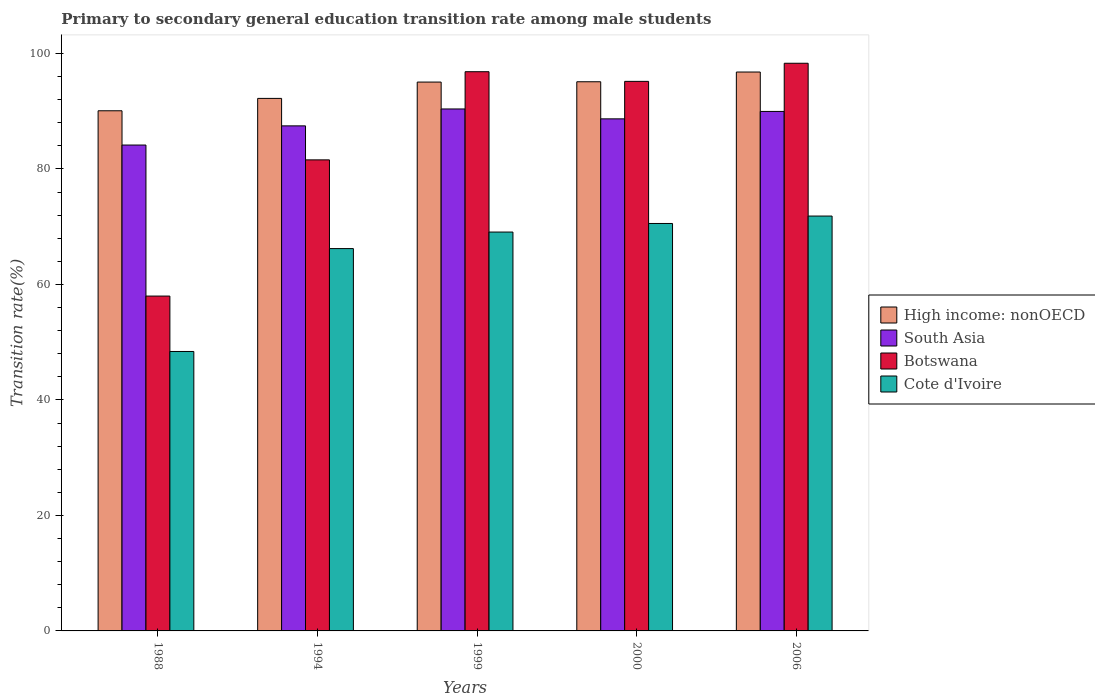How many different coloured bars are there?
Provide a short and direct response. 4. How many bars are there on the 2nd tick from the left?
Keep it short and to the point. 4. How many bars are there on the 3rd tick from the right?
Make the answer very short. 4. What is the label of the 1st group of bars from the left?
Keep it short and to the point. 1988. What is the transition rate in High income: nonOECD in 1999?
Give a very brief answer. 95.05. Across all years, what is the maximum transition rate in Botswana?
Provide a succinct answer. 98.3. Across all years, what is the minimum transition rate in South Asia?
Make the answer very short. 84.14. In which year was the transition rate in Cote d'Ivoire minimum?
Your response must be concise. 1988. What is the total transition rate in High income: nonOECD in the graph?
Your answer should be very brief. 469.22. What is the difference between the transition rate in Botswana in 1988 and that in 2000?
Give a very brief answer. -37.18. What is the difference between the transition rate in High income: nonOECD in 2000 and the transition rate in Botswana in 2006?
Provide a succinct answer. -3.2. What is the average transition rate in South Asia per year?
Your answer should be very brief. 88.13. In the year 2000, what is the difference between the transition rate in Botswana and transition rate in High income: nonOECD?
Your answer should be very brief. 0.07. What is the ratio of the transition rate in Botswana in 1988 to that in 1999?
Offer a terse response. 0.6. What is the difference between the highest and the second highest transition rate in High income: nonOECD?
Provide a short and direct response. 1.69. What is the difference between the highest and the lowest transition rate in Botswana?
Ensure brevity in your answer.  40.32. In how many years, is the transition rate in Cote d'Ivoire greater than the average transition rate in Cote d'Ivoire taken over all years?
Keep it short and to the point. 4. Is the sum of the transition rate in South Asia in 1994 and 2000 greater than the maximum transition rate in High income: nonOECD across all years?
Your answer should be compact. Yes. What does the 1st bar from the left in 2006 represents?
Your response must be concise. High income: nonOECD. What does the 1st bar from the right in 1988 represents?
Give a very brief answer. Cote d'Ivoire. Is it the case that in every year, the sum of the transition rate in High income: nonOECD and transition rate in Cote d'Ivoire is greater than the transition rate in South Asia?
Give a very brief answer. Yes. How many years are there in the graph?
Give a very brief answer. 5. How many legend labels are there?
Make the answer very short. 4. How are the legend labels stacked?
Ensure brevity in your answer.  Vertical. What is the title of the graph?
Give a very brief answer. Primary to secondary general education transition rate among male students. Does "Virgin Islands" appear as one of the legend labels in the graph?
Ensure brevity in your answer.  No. What is the label or title of the X-axis?
Provide a succinct answer. Years. What is the label or title of the Y-axis?
Give a very brief answer. Transition rate(%). What is the Transition rate(%) in High income: nonOECD in 1988?
Give a very brief answer. 90.07. What is the Transition rate(%) of South Asia in 1988?
Provide a short and direct response. 84.14. What is the Transition rate(%) of Botswana in 1988?
Provide a succinct answer. 57.99. What is the Transition rate(%) of Cote d'Ivoire in 1988?
Give a very brief answer. 48.39. What is the Transition rate(%) in High income: nonOECD in 1994?
Offer a very short reply. 92.22. What is the Transition rate(%) in South Asia in 1994?
Provide a short and direct response. 87.46. What is the Transition rate(%) in Botswana in 1994?
Keep it short and to the point. 81.57. What is the Transition rate(%) of Cote d'Ivoire in 1994?
Provide a short and direct response. 66.21. What is the Transition rate(%) of High income: nonOECD in 1999?
Make the answer very short. 95.05. What is the Transition rate(%) in South Asia in 1999?
Provide a succinct answer. 90.39. What is the Transition rate(%) of Botswana in 1999?
Give a very brief answer. 96.84. What is the Transition rate(%) in Cote d'Ivoire in 1999?
Give a very brief answer. 69.07. What is the Transition rate(%) of High income: nonOECD in 2000?
Your answer should be very brief. 95.1. What is the Transition rate(%) in South Asia in 2000?
Your answer should be compact. 88.68. What is the Transition rate(%) in Botswana in 2000?
Ensure brevity in your answer.  95.17. What is the Transition rate(%) of Cote d'Ivoire in 2000?
Your answer should be very brief. 70.56. What is the Transition rate(%) of High income: nonOECD in 2006?
Offer a terse response. 96.79. What is the Transition rate(%) of South Asia in 2006?
Keep it short and to the point. 89.96. What is the Transition rate(%) of Botswana in 2006?
Offer a terse response. 98.3. What is the Transition rate(%) of Cote d'Ivoire in 2006?
Give a very brief answer. 71.84. Across all years, what is the maximum Transition rate(%) in High income: nonOECD?
Your answer should be compact. 96.79. Across all years, what is the maximum Transition rate(%) of South Asia?
Give a very brief answer. 90.39. Across all years, what is the maximum Transition rate(%) in Botswana?
Ensure brevity in your answer.  98.3. Across all years, what is the maximum Transition rate(%) in Cote d'Ivoire?
Make the answer very short. 71.84. Across all years, what is the minimum Transition rate(%) of High income: nonOECD?
Provide a short and direct response. 90.07. Across all years, what is the minimum Transition rate(%) of South Asia?
Ensure brevity in your answer.  84.14. Across all years, what is the minimum Transition rate(%) in Botswana?
Provide a succinct answer. 57.99. Across all years, what is the minimum Transition rate(%) of Cote d'Ivoire?
Make the answer very short. 48.39. What is the total Transition rate(%) of High income: nonOECD in the graph?
Your answer should be compact. 469.22. What is the total Transition rate(%) in South Asia in the graph?
Make the answer very short. 440.63. What is the total Transition rate(%) of Botswana in the graph?
Make the answer very short. 429.87. What is the total Transition rate(%) of Cote d'Ivoire in the graph?
Keep it short and to the point. 326.08. What is the difference between the Transition rate(%) of High income: nonOECD in 1988 and that in 1994?
Ensure brevity in your answer.  -2.14. What is the difference between the Transition rate(%) in South Asia in 1988 and that in 1994?
Keep it short and to the point. -3.32. What is the difference between the Transition rate(%) of Botswana in 1988 and that in 1994?
Ensure brevity in your answer.  -23.59. What is the difference between the Transition rate(%) in Cote d'Ivoire in 1988 and that in 1994?
Offer a very short reply. -17.82. What is the difference between the Transition rate(%) of High income: nonOECD in 1988 and that in 1999?
Your answer should be compact. -4.97. What is the difference between the Transition rate(%) in South Asia in 1988 and that in 1999?
Give a very brief answer. -6.25. What is the difference between the Transition rate(%) in Botswana in 1988 and that in 1999?
Provide a succinct answer. -38.85. What is the difference between the Transition rate(%) of Cote d'Ivoire in 1988 and that in 1999?
Ensure brevity in your answer.  -20.68. What is the difference between the Transition rate(%) in High income: nonOECD in 1988 and that in 2000?
Your answer should be very brief. -5.03. What is the difference between the Transition rate(%) of South Asia in 1988 and that in 2000?
Make the answer very short. -4.53. What is the difference between the Transition rate(%) of Botswana in 1988 and that in 2000?
Make the answer very short. -37.18. What is the difference between the Transition rate(%) in Cote d'Ivoire in 1988 and that in 2000?
Ensure brevity in your answer.  -22.16. What is the difference between the Transition rate(%) of High income: nonOECD in 1988 and that in 2006?
Provide a succinct answer. -6.71. What is the difference between the Transition rate(%) of South Asia in 1988 and that in 2006?
Make the answer very short. -5.82. What is the difference between the Transition rate(%) in Botswana in 1988 and that in 2006?
Provide a short and direct response. -40.32. What is the difference between the Transition rate(%) of Cote d'Ivoire in 1988 and that in 2006?
Offer a very short reply. -23.45. What is the difference between the Transition rate(%) of High income: nonOECD in 1994 and that in 1999?
Offer a terse response. -2.83. What is the difference between the Transition rate(%) in South Asia in 1994 and that in 1999?
Offer a terse response. -2.93. What is the difference between the Transition rate(%) of Botswana in 1994 and that in 1999?
Provide a short and direct response. -15.27. What is the difference between the Transition rate(%) of Cote d'Ivoire in 1994 and that in 1999?
Keep it short and to the point. -2.86. What is the difference between the Transition rate(%) of High income: nonOECD in 1994 and that in 2000?
Ensure brevity in your answer.  -2.88. What is the difference between the Transition rate(%) of South Asia in 1994 and that in 2000?
Provide a short and direct response. -1.21. What is the difference between the Transition rate(%) of Botswana in 1994 and that in 2000?
Your answer should be compact. -13.6. What is the difference between the Transition rate(%) of Cote d'Ivoire in 1994 and that in 2000?
Ensure brevity in your answer.  -4.35. What is the difference between the Transition rate(%) in High income: nonOECD in 1994 and that in 2006?
Offer a very short reply. -4.57. What is the difference between the Transition rate(%) in South Asia in 1994 and that in 2006?
Your answer should be very brief. -2.5. What is the difference between the Transition rate(%) in Botswana in 1994 and that in 2006?
Your answer should be compact. -16.73. What is the difference between the Transition rate(%) of Cote d'Ivoire in 1994 and that in 2006?
Your answer should be compact. -5.63. What is the difference between the Transition rate(%) in High income: nonOECD in 1999 and that in 2000?
Your response must be concise. -0.05. What is the difference between the Transition rate(%) in South Asia in 1999 and that in 2000?
Offer a very short reply. 1.71. What is the difference between the Transition rate(%) of Botswana in 1999 and that in 2000?
Provide a short and direct response. 1.67. What is the difference between the Transition rate(%) of Cote d'Ivoire in 1999 and that in 2000?
Your answer should be very brief. -1.49. What is the difference between the Transition rate(%) in High income: nonOECD in 1999 and that in 2006?
Your answer should be compact. -1.74. What is the difference between the Transition rate(%) in South Asia in 1999 and that in 2006?
Provide a short and direct response. 0.43. What is the difference between the Transition rate(%) in Botswana in 1999 and that in 2006?
Offer a very short reply. -1.46. What is the difference between the Transition rate(%) of Cote d'Ivoire in 1999 and that in 2006?
Give a very brief answer. -2.77. What is the difference between the Transition rate(%) in High income: nonOECD in 2000 and that in 2006?
Give a very brief answer. -1.69. What is the difference between the Transition rate(%) of South Asia in 2000 and that in 2006?
Your answer should be compact. -1.29. What is the difference between the Transition rate(%) in Botswana in 2000 and that in 2006?
Ensure brevity in your answer.  -3.14. What is the difference between the Transition rate(%) in Cote d'Ivoire in 2000 and that in 2006?
Your answer should be very brief. -1.28. What is the difference between the Transition rate(%) of High income: nonOECD in 1988 and the Transition rate(%) of South Asia in 1994?
Provide a short and direct response. 2.61. What is the difference between the Transition rate(%) in High income: nonOECD in 1988 and the Transition rate(%) in Botswana in 1994?
Offer a very short reply. 8.5. What is the difference between the Transition rate(%) in High income: nonOECD in 1988 and the Transition rate(%) in Cote d'Ivoire in 1994?
Make the answer very short. 23.87. What is the difference between the Transition rate(%) in South Asia in 1988 and the Transition rate(%) in Botswana in 1994?
Provide a succinct answer. 2.57. What is the difference between the Transition rate(%) of South Asia in 1988 and the Transition rate(%) of Cote d'Ivoire in 1994?
Keep it short and to the point. 17.93. What is the difference between the Transition rate(%) of Botswana in 1988 and the Transition rate(%) of Cote d'Ivoire in 1994?
Keep it short and to the point. -8.22. What is the difference between the Transition rate(%) in High income: nonOECD in 1988 and the Transition rate(%) in South Asia in 1999?
Your answer should be compact. -0.32. What is the difference between the Transition rate(%) of High income: nonOECD in 1988 and the Transition rate(%) of Botswana in 1999?
Your response must be concise. -6.77. What is the difference between the Transition rate(%) of High income: nonOECD in 1988 and the Transition rate(%) of Cote d'Ivoire in 1999?
Ensure brevity in your answer.  21. What is the difference between the Transition rate(%) in South Asia in 1988 and the Transition rate(%) in Botswana in 1999?
Offer a terse response. -12.7. What is the difference between the Transition rate(%) in South Asia in 1988 and the Transition rate(%) in Cote d'Ivoire in 1999?
Offer a very short reply. 15.07. What is the difference between the Transition rate(%) of Botswana in 1988 and the Transition rate(%) of Cote d'Ivoire in 1999?
Give a very brief answer. -11.09. What is the difference between the Transition rate(%) in High income: nonOECD in 1988 and the Transition rate(%) in South Asia in 2000?
Keep it short and to the point. 1.4. What is the difference between the Transition rate(%) in High income: nonOECD in 1988 and the Transition rate(%) in Botswana in 2000?
Offer a very short reply. -5.09. What is the difference between the Transition rate(%) in High income: nonOECD in 1988 and the Transition rate(%) in Cote d'Ivoire in 2000?
Offer a very short reply. 19.52. What is the difference between the Transition rate(%) in South Asia in 1988 and the Transition rate(%) in Botswana in 2000?
Offer a terse response. -11.03. What is the difference between the Transition rate(%) of South Asia in 1988 and the Transition rate(%) of Cote d'Ivoire in 2000?
Provide a short and direct response. 13.58. What is the difference between the Transition rate(%) of Botswana in 1988 and the Transition rate(%) of Cote d'Ivoire in 2000?
Provide a succinct answer. -12.57. What is the difference between the Transition rate(%) in High income: nonOECD in 1988 and the Transition rate(%) in South Asia in 2006?
Offer a terse response. 0.11. What is the difference between the Transition rate(%) of High income: nonOECD in 1988 and the Transition rate(%) of Botswana in 2006?
Your response must be concise. -8.23. What is the difference between the Transition rate(%) of High income: nonOECD in 1988 and the Transition rate(%) of Cote d'Ivoire in 2006?
Keep it short and to the point. 18.23. What is the difference between the Transition rate(%) of South Asia in 1988 and the Transition rate(%) of Botswana in 2006?
Your answer should be very brief. -14.16. What is the difference between the Transition rate(%) in South Asia in 1988 and the Transition rate(%) in Cote d'Ivoire in 2006?
Provide a short and direct response. 12.3. What is the difference between the Transition rate(%) in Botswana in 1988 and the Transition rate(%) in Cote d'Ivoire in 2006?
Keep it short and to the point. -13.86. What is the difference between the Transition rate(%) in High income: nonOECD in 1994 and the Transition rate(%) in South Asia in 1999?
Provide a succinct answer. 1.83. What is the difference between the Transition rate(%) of High income: nonOECD in 1994 and the Transition rate(%) of Botswana in 1999?
Offer a terse response. -4.62. What is the difference between the Transition rate(%) in High income: nonOECD in 1994 and the Transition rate(%) in Cote d'Ivoire in 1999?
Provide a succinct answer. 23.15. What is the difference between the Transition rate(%) of South Asia in 1994 and the Transition rate(%) of Botswana in 1999?
Provide a succinct answer. -9.38. What is the difference between the Transition rate(%) in South Asia in 1994 and the Transition rate(%) in Cote d'Ivoire in 1999?
Your answer should be compact. 18.39. What is the difference between the Transition rate(%) in Botswana in 1994 and the Transition rate(%) in Cote d'Ivoire in 1999?
Offer a very short reply. 12.5. What is the difference between the Transition rate(%) of High income: nonOECD in 1994 and the Transition rate(%) of South Asia in 2000?
Your response must be concise. 3.54. What is the difference between the Transition rate(%) of High income: nonOECD in 1994 and the Transition rate(%) of Botswana in 2000?
Make the answer very short. -2.95. What is the difference between the Transition rate(%) of High income: nonOECD in 1994 and the Transition rate(%) of Cote d'Ivoire in 2000?
Make the answer very short. 21.66. What is the difference between the Transition rate(%) of South Asia in 1994 and the Transition rate(%) of Botswana in 2000?
Your answer should be very brief. -7.71. What is the difference between the Transition rate(%) in South Asia in 1994 and the Transition rate(%) in Cote d'Ivoire in 2000?
Provide a short and direct response. 16.9. What is the difference between the Transition rate(%) in Botswana in 1994 and the Transition rate(%) in Cote d'Ivoire in 2000?
Your answer should be compact. 11.01. What is the difference between the Transition rate(%) of High income: nonOECD in 1994 and the Transition rate(%) of South Asia in 2006?
Your answer should be very brief. 2.26. What is the difference between the Transition rate(%) of High income: nonOECD in 1994 and the Transition rate(%) of Botswana in 2006?
Your answer should be compact. -6.09. What is the difference between the Transition rate(%) of High income: nonOECD in 1994 and the Transition rate(%) of Cote d'Ivoire in 2006?
Your response must be concise. 20.38. What is the difference between the Transition rate(%) of South Asia in 1994 and the Transition rate(%) of Botswana in 2006?
Ensure brevity in your answer.  -10.84. What is the difference between the Transition rate(%) in South Asia in 1994 and the Transition rate(%) in Cote d'Ivoire in 2006?
Keep it short and to the point. 15.62. What is the difference between the Transition rate(%) in Botswana in 1994 and the Transition rate(%) in Cote d'Ivoire in 2006?
Make the answer very short. 9.73. What is the difference between the Transition rate(%) in High income: nonOECD in 1999 and the Transition rate(%) in South Asia in 2000?
Ensure brevity in your answer.  6.37. What is the difference between the Transition rate(%) in High income: nonOECD in 1999 and the Transition rate(%) in Botswana in 2000?
Provide a succinct answer. -0.12. What is the difference between the Transition rate(%) in High income: nonOECD in 1999 and the Transition rate(%) in Cote d'Ivoire in 2000?
Your answer should be very brief. 24.49. What is the difference between the Transition rate(%) in South Asia in 1999 and the Transition rate(%) in Botswana in 2000?
Provide a short and direct response. -4.78. What is the difference between the Transition rate(%) of South Asia in 1999 and the Transition rate(%) of Cote d'Ivoire in 2000?
Offer a very short reply. 19.83. What is the difference between the Transition rate(%) of Botswana in 1999 and the Transition rate(%) of Cote d'Ivoire in 2000?
Your response must be concise. 26.28. What is the difference between the Transition rate(%) in High income: nonOECD in 1999 and the Transition rate(%) in South Asia in 2006?
Make the answer very short. 5.08. What is the difference between the Transition rate(%) in High income: nonOECD in 1999 and the Transition rate(%) in Botswana in 2006?
Offer a terse response. -3.26. What is the difference between the Transition rate(%) in High income: nonOECD in 1999 and the Transition rate(%) in Cote d'Ivoire in 2006?
Make the answer very short. 23.2. What is the difference between the Transition rate(%) in South Asia in 1999 and the Transition rate(%) in Botswana in 2006?
Offer a very short reply. -7.91. What is the difference between the Transition rate(%) of South Asia in 1999 and the Transition rate(%) of Cote d'Ivoire in 2006?
Ensure brevity in your answer.  18.55. What is the difference between the Transition rate(%) in Botswana in 1999 and the Transition rate(%) in Cote d'Ivoire in 2006?
Your response must be concise. 25. What is the difference between the Transition rate(%) of High income: nonOECD in 2000 and the Transition rate(%) of South Asia in 2006?
Your response must be concise. 5.14. What is the difference between the Transition rate(%) in High income: nonOECD in 2000 and the Transition rate(%) in Botswana in 2006?
Offer a terse response. -3.2. What is the difference between the Transition rate(%) of High income: nonOECD in 2000 and the Transition rate(%) of Cote d'Ivoire in 2006?
Offer a very short reply. 23.26. What is the difference between the Transition rate(%) of South Asia in 2000 and the Transition rate(%) of Botswana in 2006?
Your response must be concise. -9.63. What is the difference between the Transition rate(%) of South Asia in 2000 and the Transition rate(%) of Cote d'Ivoire in 2006?
Provide a short and direct response. 16.83. What is the difference between the Transition rate(%) of Botswana in 2000 and the Transition rate(%) of Cote d'Ivoire in 2006?
Keep it short and to the point. 23.33. What is the average Transition rate(%) of High income: nonOECD per year?
Provide a succinct answer. 93.84. What is the average Transition rate(%) of South Asia per year?
Offer a terse response. 88.13. What is the average Transition rate(%) in Botswana per year?
Give a very brief answer. 85.97. What is the average Transition rate(%) of Cote d'Ivoire per year?
Your answer should be compact. 65.22. In the year 1988, what is the difference between the Transition rate(%) of High income: nonOECD and Transition rate(%) of South Asia?
Provide a short and direct response. 5.93. In the year 1988, what is the difference between the Transition rate(%) of High income: nonOECD and Transition rate(%) of Botswana?
Your response must be concise. 32.09. In the year 1988, what is the difference between the Transition rate(%) of High income: nonOECD and Transition rate(%) of Cote d'Ivoire?
Provide a short and direct response. 41.68. In the year 1988, what is the difference between the Transition rate(%) in South Asia and Transition rate(%) in Botswana?
Your answer should be compact. 26.16. In the year 1988, what is the difference between the Transition rate(%) of South Asia and Transition rate(%) of Cote d'Ivoire?
Provide a short and direct response. 35.75. In the year 1988, what is the difference between the Transition rate(%) in Botswana and Transition rate(%) in Cote d'Ivoire?
Give a very brief answer. 9.59. In the year 1994, what is the difference between the Transition rate(%) of High income: nonOECD and Transition rate(%) of South Asia?
Provide a succinct answer. 4.76. In the year 1994, what is the difference between the Transition rate(%) of High income: nonOECD and Transition rate(%) of Botswana?
Offer a terse response. 10.65. In the year 1994, what is the difference between the Transition rate(%) of High income: nonOECD and Transition rate(%) of Cote d'Ivoire?
Ensure brevity in your answer.  26.01. In the year 1994, what is the difference between the Transition rate(%) in South Asia and Transition rate(%) in Botswana?
Give a very brief answer. 5.89. In the year 1994, what is the difference between the Transition rate(%) in South Asia and Transition rate(%) in Cote d'Ivoire?
Provide a short and direct response. 21.25. In the year 1994, what is the difference between the Transition rate(%) in Botswana and Transition rate(%) in Cote d'Ivoire?
Your answer should be compact. 15.36. In the year 1999, what is the difference between the Transition rate(%) in High income: nonOECD and Transition rate(%) in South Asia?
Provide a succinct answer. 4.66. In the year 1999, what is the difference between the Transition rate(%) of High income: nonOECD and Transition rate(%) of Botswana?
Offer a terse response. -1.79. In the year 1999, what is the difference between the Transition rate(%) of High income: nonOECD and Transition rate(%) of Cote d'Ivoire?
Provide a short and direct response. 25.97. In the year 1999, what is the difference between the Transition rate(%) in South Asia and Transition rate(%) in Botswana?
Ensure brevity in your answer.  -6.45. In the year 1999, what is the difference between the Transition rate(%) in South Asia and Transition rate(%) in Cote d'Ivoire?
Provide a short and direct response. 21.32. In the year 1999, what is the difference between the Transition rate(%) of Botswana and Transition rate(%) of Cote d'Ivoire?
Your response must be concise. 27.77. In the year 2000, what is the difference between the Transition rate(%) in High income: nonOECD and Transition rate(%) in South Asia?
Offer a very short reply. 6.42. In the year 2000, what is the difference between the Transition rate(%) in High income: nonOECD and Transition rate(%) in Botswana?
Your answer should be very brief. -0.07. In the year 2000, what is the difference between the Transition rate(%) in High income: nonOECD and Transition rate(%) in Cote d'Ivoire?
Keep it short and to the point. 24.54. In the year 2000, what is the difference between the Transition rate(%) of South Asia and Transition rate(%) of Botswana?
Your response must be concise. -6.49. In the year 2000, what is the difference between the Transition rate(%) in South Asia and Transition rate(%) in Cote d'Ivoire?
Offer a very short reply. 18.12. In the year 2000, what is the difference between the Transition rate(%) in Botswana and Transition rate(%) in Cote d'Ivoire?
Ensure brevity in your answer.  24.61. In the year 2006, what is the difference between the Transition rate(%) in High income: nonOECD and Transition rate(%) in South Asia?
Your answer should be very brief. 6.82. In the year 2006, what is the difference between the Transition rate(%) of High income: nonOECD and Transition rate(%) of Botswana?
Provide a short and direct response. -1.52. In the year 2006, what is the difference between the Transition rate(%) in High income: nonOECD and Transition rate(%) in Cote d'Ivoire?
Your answer should be very brief. 24.94. In the year 2006, what is the difference between the Transition rate(%) in South Asia and Transition rate(%) in Botswana?
Offer a very short reply. -8.34. In the year 2006, what is the difference between the Transition rate(%) of South Asia and Transition rate(%) of Cote d'Ivoire?
Your answer should be very brief. 18.12. In the year 2006, what is the difference between the Transition rate(%) in Botswana and Transition rate(%) in Cote d'Ivoire?
Offer a terse response. 26.46. What is the ratio of the Transition rate(%) in High income: nonOECD in 1988 to that in 1994?
Ensure brevity in your answer.  0.98. What is the ratio of the Transition rate(%) in South Asia in 1988 to that in 1994?
Your answer should be very brief. 0.96. What is the ratio of the Transition rate(%) in Botswana in 1988 to that in 1994?
Offer a terse response. 0.71. What is the ratio of the Transition rate(%) in Cote d'Ivoire in 1988 to that in 1994?
Provide a short and direct response. 0.73. What is the ratio of the Transition rate(%) in High income: nonOECD in 1988 to that in 1999?
Make the answer very short. 0.95. What is the ratio of the Transition rate(%) of South Asia in 1988 to that in 1999?
Give a very brief answer. 0.93. What is the ratio of the Transition rate(%) in Botswana in 1988 to that in 1999?
Keep it short and to the point. 0.6. What is the ratio of the Transition rate(%) of Cote d'Ivoire in 1988 to that in 1999?
Make the answer very short. 0.7. What is the ratio of the Transition rate(%) in High income: nonOECD in 1988 to that in 2000?
Provide a succinct answer. 0.95. What is the ratio of the Transition rate(%) of South Asia in 1988 to that in 2000?
Your answer should be compact. 0.95. What is the ratio of the Transition rate(%) in Botswana in 1988 to that in 2000?
Your answer should be compact. 0.61. What is the ratio of the Transition rate(%) of Cote d'Ivoire in 1988 to that in 2000?
Offer a very short reply. 0.69. What is the ratio of the Transition rate(%) in High income: nonOECD in 1988 to that in 2006?
Provide a succinct answer. 0.93. What is the ratio of the Transition rate(%) in South Asia in 1988 to that in 2006?
Make the answer very short. 0.94. What is the ratio of the Transition rate(%) of Botswana in 1988 to that in 2006?
Your answer should be compact. 0.59. What is the ratio of the Transition rate(%) in Cote d'Ivoire in 1988 to that in 2006?
Offer a very short reply. 0.67. What is the ratio of the Transition rate(%) of High income: nonOECD in 1994 to that in 1999?
Offer a very short reply. 0.97. What is the ratio of the Transition rate(%) of South Asia in 1994 to that in 1999?
Provide a succinct answer. 0.97. What is the ratio of the Transition rate(%) of Botswana in 1994 to that in 1999?
Ensure brevity in your answer.  0.84. What is the ratio of the Transition rate(%) in Cote d'Ivoire in 1994 to that in 1999?
Provide a short and direct response. 0.96. What is the ratio of the Transition rate(%) of High income: nonOECD in 1994 to that in 2000?
Provide a short and direct response. 0.97. What is the ratio of the Transition rate(%) of South Asia in 1994 to that in 2000?
Your answer should be compact. 0.99. What is the ratio of the Transition rate(%) of Cote d'Ivoire in 1994 to that in 2000?
Your response must be concise. 0.94. What is the ratio of the Transition rate(%) in High income: nonOECD in 1994 to that in 2006?
Ensure brevity in your answer.  0.95. What is the ratio of the Transition rate(%) in South Asia in 1994 to that in 2006?
Give a very brief answer. 0.97. What is the ratio of the Transition rate(%) in Botswana in 1994 to that in 2006?
Offer a terse response. 0.83. What is the ratio of the Transition rate(%) of Cote d'Ivoire in 1994 to that in 2006?
Offer a terse response. 0.92. What is the ratio of the Transition rate(%) of High income: nonOECD in 1999 to that in 2000?
Your response must be concise. 1. What is the ratio of the Transition rate(%) of South Asia in 1999 to that in 2000?
Provide a succinct answer. 1.02. What is the ratio of the Transition rate(%) of Botswana in 1999 to that in 2000?
Your response must be concise. 1.02. What is the ratio of the Transition rate(%) of Cote d'Ivoire in 1999 to that in 2000?
Make the answer very short. 0.98. What is the ratio of the Transition rate(%) of High income: nonOECD in 1999 to that in 2006?
Offer a terse response. 0.98. What is the ratio of the Transition rate(%) in South Asia in 1999 to that in 2006?
Provide a succinct answer. 1. What is the ratio of the Transition rate(%) of Botswana in 1999 to that in 2006?
Keep it short and to the point. 0.99. What is the ratio of the Transition rate(%) of Cote d'Ivoire in 1999 to that in 2006?
Offer a terse response. 0.96. What is the ratio of the Transition rate(%) in High income: nonOECD in 2000 to that in 2006?
Offer a very short reply. 0.98. What is the ratio of the Transition rate(%) of South Asia in 2000 to that in 2006?
Make the answer very short. 0.99. What is the ratio of the Transition rate(%) of Botswana in 2000 to that in 2006?
Provide a succinct answer. 0.97. What is the ratio of the Transition rate(%) of Cote d'Ivoire in 2000 to that in 2006?
Ensure brevity in your answer.  0.98. What is the difference between the highest and the second highest Transition rate(%) in High income: nonOECD?
Your answer should be very brief. 1.69. What is the difference between the highest and the second highest Transition rate(%) in South Asia?
Your answer should be very brief. 0.43. What is the difference between the highest and the second highest Transition rate(%) of Botswana?
Offer a very short reply. 1.46. What is the difference between the highest and the second highest Transition rate(%) in Cote d'Ivoire?
Offer a terse response. 1.28. What is the difference between the highest and the lowest Transition rate(%) in High income: nonOECD?
Give a very brief answer. 6.71. What is the difference between the highest and the lowest Transition rate(%) in South Asia?
Keep it short and to the point. 6.25. What is the difference between the highest and the lowest Transition rate(%) of Botswana?
Ensure brevity in your answer.  40.32. What is the difference between the highest and the lowest Transition rate(%) in Cote d'Ivoire?
Make the answer very short. 23.45. 